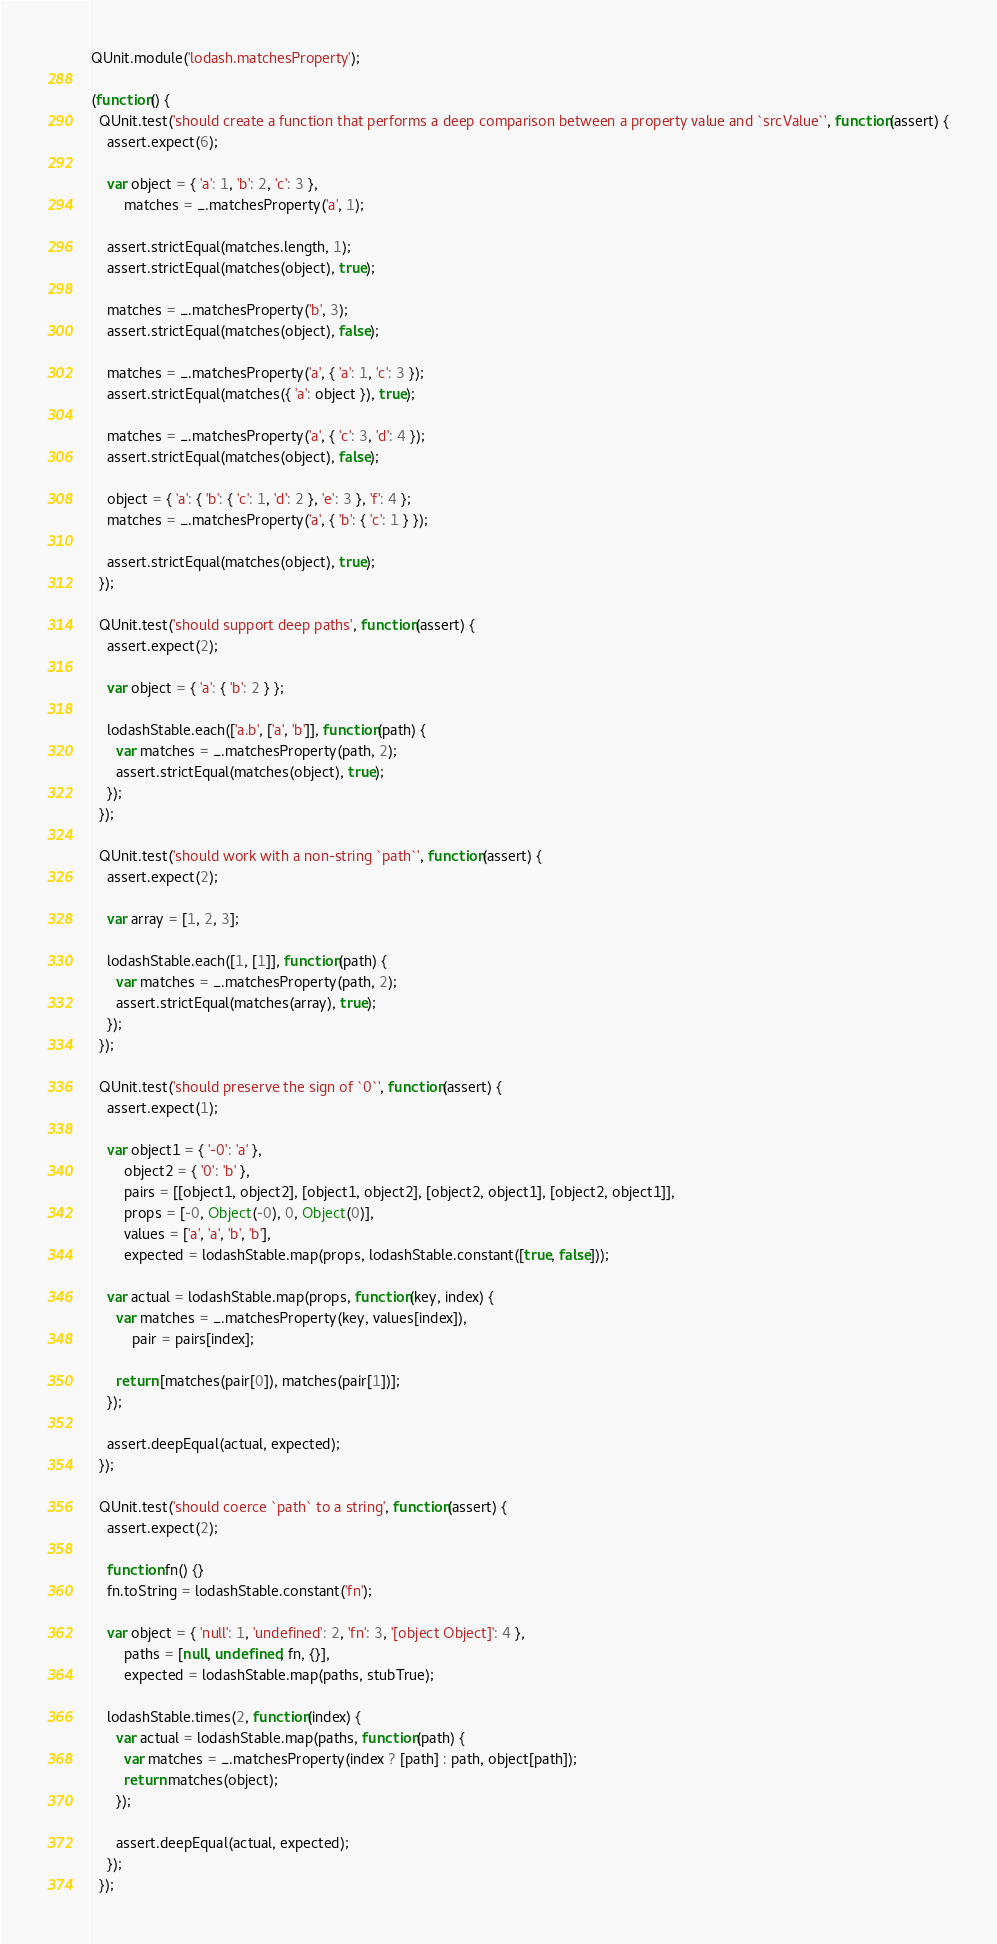Convert code to text. <code><loc_0><loc_0><loc_500><loc_500><_JavaScript_>QUnit.module('lodash.matchesProperty');

(function() {
  QUnit.test('should create a function that performs a deep comparison between a property value and `srcValue`', function(assert) {
    assert.expect(6);

    var object = { 'a': 1, 'b': 2, 'c': 3 },
        matches = _.matchesProperty('a', 1);

    assert.strictEqual(matches.length, 1);
    assert.strictEqual(matches(object), true);

    matches = _.matchesProperty('b', 3);
    assert.strictEqual(matches(object), false);

    matches = _.matchesProperty('a', { 'a': 1, 'c': 3 });
    assert.strictEqual(matches({ 'a': object }), true);

    matches = _.matchesProperty('a', { 'c': 3, 'd': 4 });
    assert.strictEqual(matches(object), false);

    object = { 'a': { 'b': { 'c': 1, 'd': 2 }, 'e': 3 }, 'f': 4 };
    matches = _.matchesProperty('a', { 'b': { 'c': 1 } });

    assert.strictEqual(matches(object), true);
  });

  QUnit.test('should support deep paths', function(assert) {
    assert.expect(2);

    var object = { 'a': { 'b': 2 } };

    lodashStable.each(['a.b', ['a', 'b']], function(path) {
      var matches = _.matchesProperty(path, 2);
      assert.strictEqual(matches(object), true);
    });
  });

  QUnit.test('should work with a non-string `path`', function(assert) {
    assert.expect(2);

    var array = [1, 2, 3];

    lodashStable.each([1, [1]], function(path) {
      var matches = _.matchesProperty(path, 2);
      assert.strictEqual(matches(array), true);
    });
  });

  QUnit.test('should preserve the sign of `0`', function(assert) {
    assert.expect(1);

    var object1 = { '-0': 'a' },
        object2 = { '0': 'b' },
        pairs = [[object1, object2], [object1, object2], [object2, object1], [object2, object1]],
        props = [-0, Object(-0), 0, Object(0)],
        values = ['a', 'a', 'b', 'b'],
        expected = lodashStable.map(props, lodashStable.constant([true, false]));

    var actual = lodashStable.map(props, function(key, index) {
      var matches = _.matchesProperty(key, values[index]),
          pair = pairs[index];

      return [matches(pair[0]), matches(pair[1])];
    });

    assert.deepEqual(actual, expected);
  });

  QUnit.test('should coerce `path` to a string', function(assert) {
    assert.expect(2);

    function fn() {}
    fn.toString = lodashStable.constant('fn');

    var object = { 'null': 1, 'undefined': 2, 'fn': 3, '[object Object]': 4 },
        paths = [null, undefined, fn, {}],
        expected = lodashStable.map(paths, stubTrue);

    lodashStable.times(2, function(index) {
      var actual = lodashStable.map(paths, function(path) {
        var matches = _.matchesProperty(index ? [path] : path, object[path]);
        return matches(object);
      });

      assert.deepEqual(actual, expected);
    });
  });
</code> 